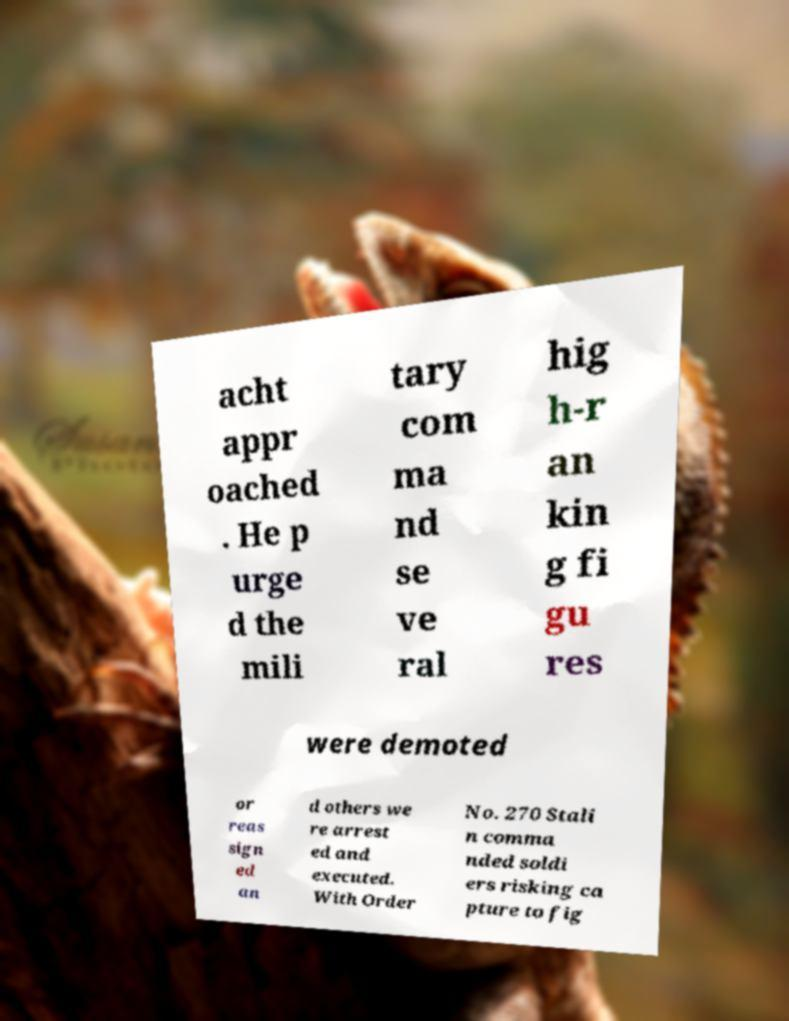Could you extract and type out the text from this image? acht appr oached . He p urge d the mili tary com ma nd se ve ral hig h-r an kin g fi gu res were demoted or reas sign ed an d others we re arrest ed and executed. With Order No. 270 Stali n comma nded soldi ers risking ca pture to fig 